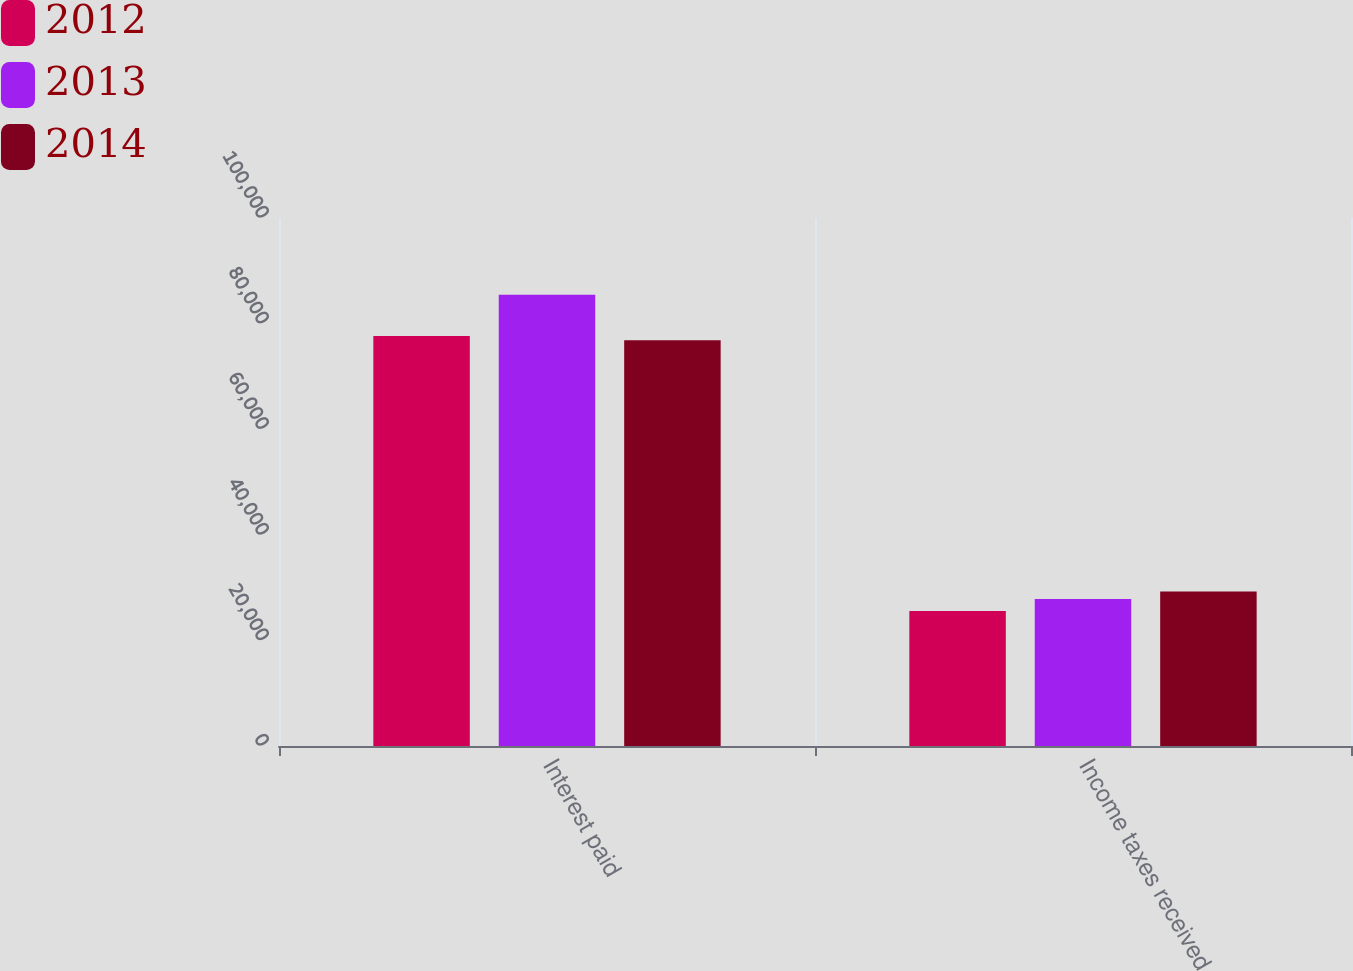Convert chart to OTSL. <chart><loc_0><loc_0><loc_500><loc_500><stacked_bar_chart><ecel><fcel>Interest paid<fcel>Income taxes received<nl><fcel>2012<fcel>77663<fcel>25581<nl><fcel>2013<fcel>85443<fcel>27820<nl><fcel>2014<fcel>76833<fcel>29251<nl></chart> 